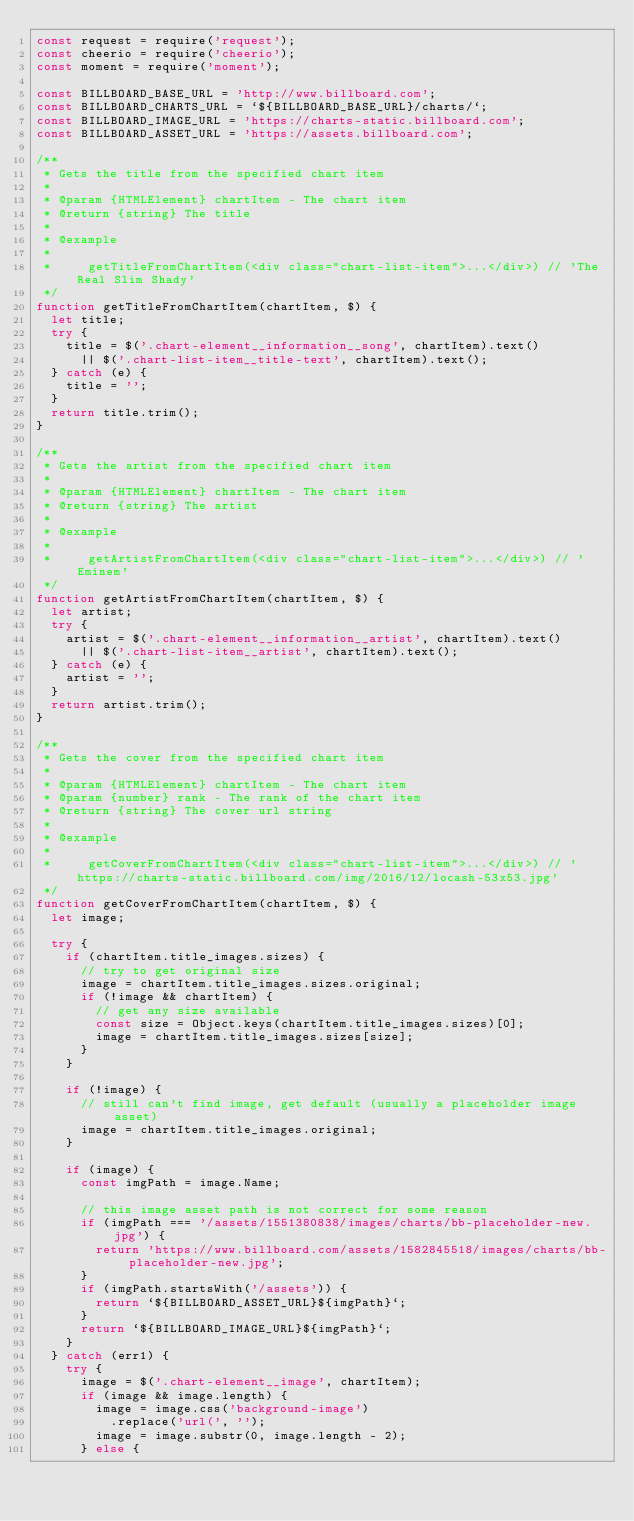<code> <loc_0><loc_0><loc_500><loc_500><_JavaScript_>const request = require('request');
const cheerio = require('cheerio');
const moment = require('moment');

const BILLBOARD_BASE_URL = 'http://www.billboard.com';
const BILLBOARD_CHARTS_URL = `${BILLBOARD_BASE_URL}/charts/`;
const BILLBOARD_IMAGE_URL = 'https://charts-static.billboard.com';
const BILLBOARD_ASSET_URL = 'https://assets.billboard.com';

/**
 * Gets the title from the specified chart item
 *
 * @param {HTMLElement} chartItem - The chart item
 * @return {string} The title
 *
 * @example
 *
 *     getTitleFromChartItem(<div class="chart-list-item">...</div>) // 'The Real Slim Shady'
 */
function getTitleFromChartItem(chartItem, $) {
  let title;
  try {
    title = $('.chart-element__information__song', chartItem).text()
      || $('.chart-list-item__title-text', chartItem).text();
  } catch (e) {
    title = '';
  }
  return title.trim();
}

/**
 * Gets the artist from the specified chart item
 *
 * @param {HTMLElement} chartItem - The chart item
 * @return {string} The artist
 *
 * @example
 *
 *     getArtistFromChartItem(<div class="chart-list-item">...</div>) // 'Eminem'
 */
function getArtistFromChartItem(chartItem, $) {
  let artist;
  try {
    artist = $('.chart-element__information__artist', chartItem).text()
      || $('.chart-list-item__artist', chartItem).text();
  } catch (e) {
    artist = '';
  }
  return artist.trim();
}

/**
 * Gets the cover from the specified chart item
 *
 * @param {HTMLElement} chartItem - The chart item
 * @param {number} rank - The rank of the chart item
 * @return {string} The cover url string
 *
 * @example
 *
 *     getCoverFromChartItem(<div class="chart-list-item">...</div>) // 'https://charts-static.billboard.com/img/2016/12/locash-53x53.jpg'
 */
function getCoverFromChartItem(chartItem, $) {
  let image;

  try {
    if (chartItem.title_images.sizes) {
      // try to get original size
      image = chartItem.title_images.sizes.original;
      if (!image && chartItem) {
        // get any size available
        const size = Object.keys(chartItem.title_images.sizes)[0];
        image = chartItem.title_images.sizes[size];
      }
    }

    if (!image) {
      // still can't find image, get default (usually a placeholder image asset)
      image = chartItem.title_images.original;
    }

    if (image) {
      const imgPath = image.Name;

      // this image asset path is not correct for some reason
      if (imgPath === '/assets/1551380838/images/charts/bb-placeholder-new.jpg') {
        return 'https://www.billboard.com/assets/1582845518/images/charts/bb-placeholder-new.jpg';
      }
      if (imgPath.startsWith('/assets')) {
        return `${BILLBOARD_ASSET_URL}${imgPath}`;
      }
      return `${BILLBOARD_IMAGE_URL}${imgPath}`;
    }
  } catch (err1) {
    try {
      image = $('.chart-element__image', chartItem);
      if (image && image.length) {
        image = image.css('background-image')
          .replace('url(', '');
        image = image.substr(0, image.length - 2);
      } else {</code> 